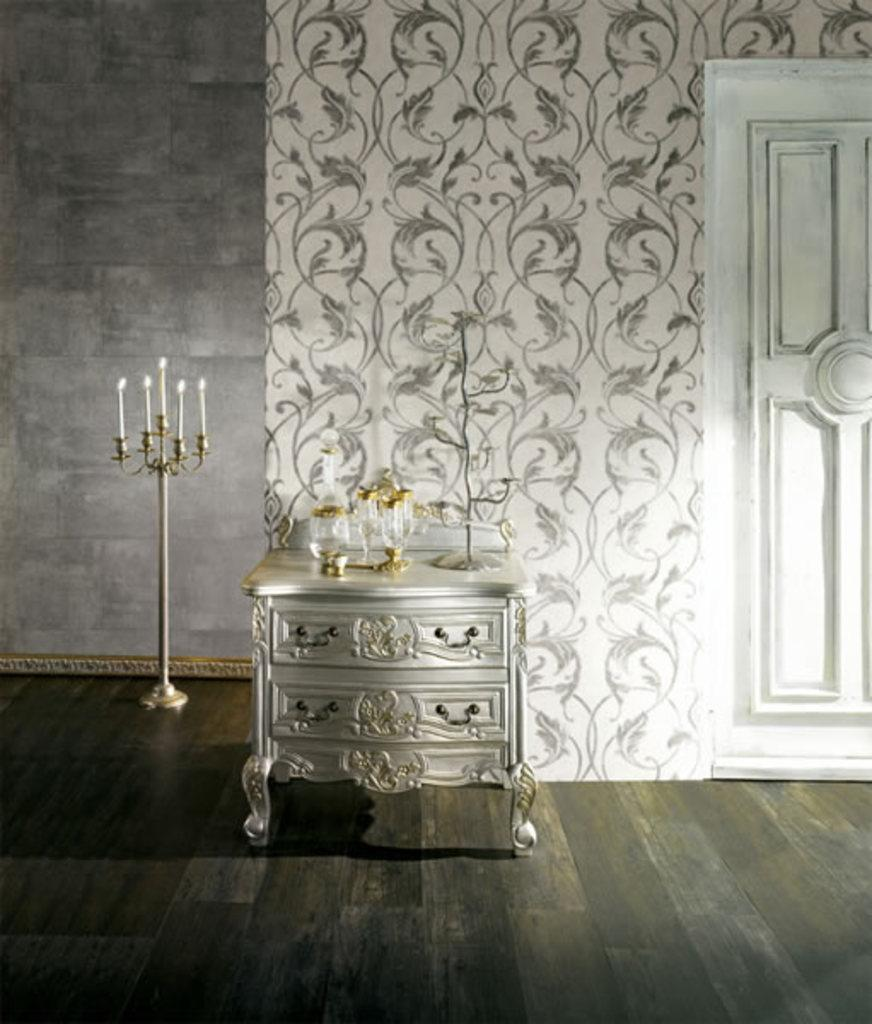What piece of furniture is present in the image? There is a table in the image. What is on top of the table? There are things on the table. What can be found on the stand in the image? There is a stand with candles on it. What type of architectural feature is visible in the image? There is a wall in the image. What is another feature that allows access to different areas? There is a door in the image. What type of beef is being cooked on the table in the image? There is no beef present in the image; it features a table with things on it, a stand with candles, a wall, and a door. 